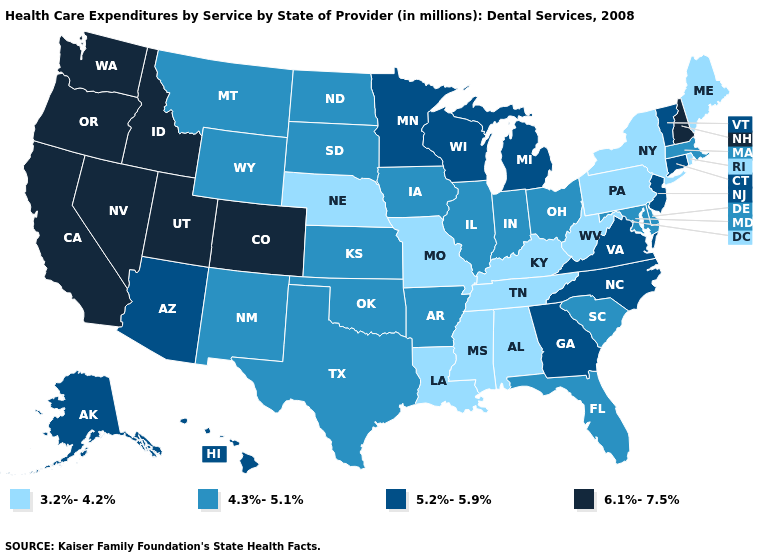Does the map have missing data?
Give a very brief answer. No. What is the value of Florida?
Be succinct. 4.3%-5.1%. Name the states that have a value in the range 4.3%-5.1%?
Answer briefly. Arkansas, Delaware, Florida, Illinois, Indiana, Iowa, Kansas, Maryland, Massachusetts, Montana, New Mexico, North Dakota, Ohio, Oklahoma, South Carolina, South Dakota, Texas, Wyoming. What is the highest value in the USA?
Short answer required. 6.1%-7.5%. What is the value of Washington?
Concise answer only. 6.1%-7.5%. What is the lowest value in the USA?
Short answer required. 3.2%-4.2%. What is the value of South Dakota?
Write a very short answer. 4.3%-5.1%. Does the first symbol in the legend represent the smallest category?
Answer briefly. Yes. Does Nebraska have the lowest value in the USA?
Write a very short answer. Yes. Does Illinois have the highest value in the USA?
Be succinct. No. Does Tennessee have a higher value than South Carolina?
Give a very brief answer. No. Does Alabama have the highest value in the South?
Short answer required. No. Name the states that have a value in the range 4.3%-5.1%?
Be succinct. Arkansas, Delaware, Florida, Illinois, Indiana, Iowa, Kansas, Maryland, Massachusetts, Montana, New Mexico, North Dakota, Ohio, Oklahoma, South Carolina, South Dakota, Texas, Wyoming. Which states have the lowest value in the MidWest?
Be succinct. Missouri, Nebraska. Does Minnesota have the highest value in the USA?
Concise answer only. No. 